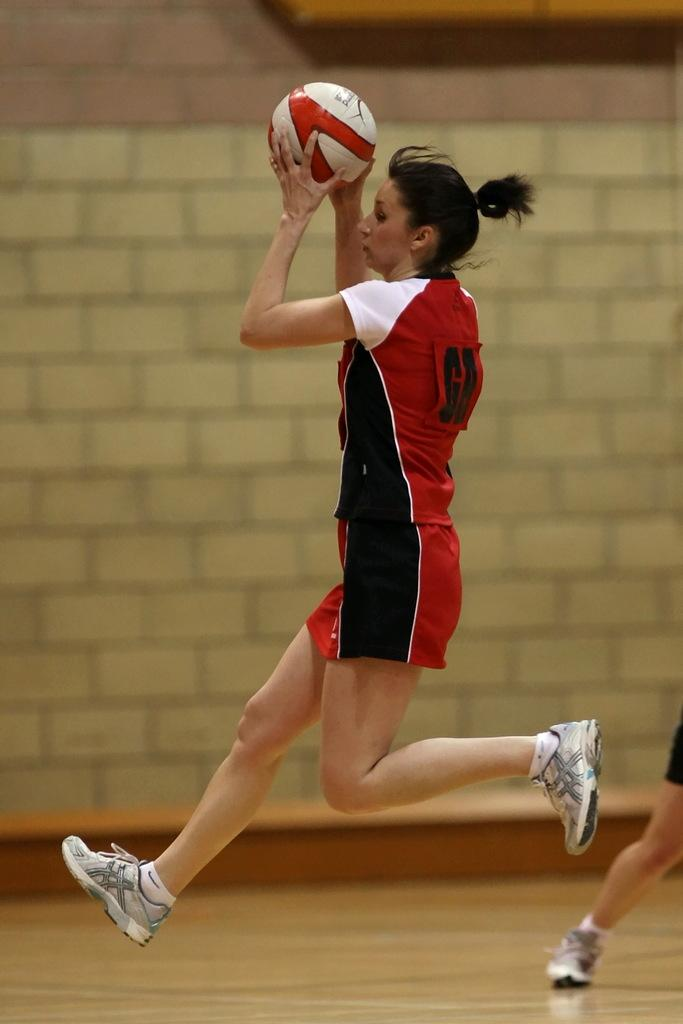Who is present in the image? There is a woman in the image. What is the woman holding in her hands? The woman is holding a ball in her hands. What can be seen beneath the woman in the image? The image shows the floor. What is visible behind the woman in the image? There is a wall in the background of the image. What type of design can be seen on the mountain in the image? There is no mountain present in the image; it only features a woman holding a ball, the floor, and a wall in the background. 